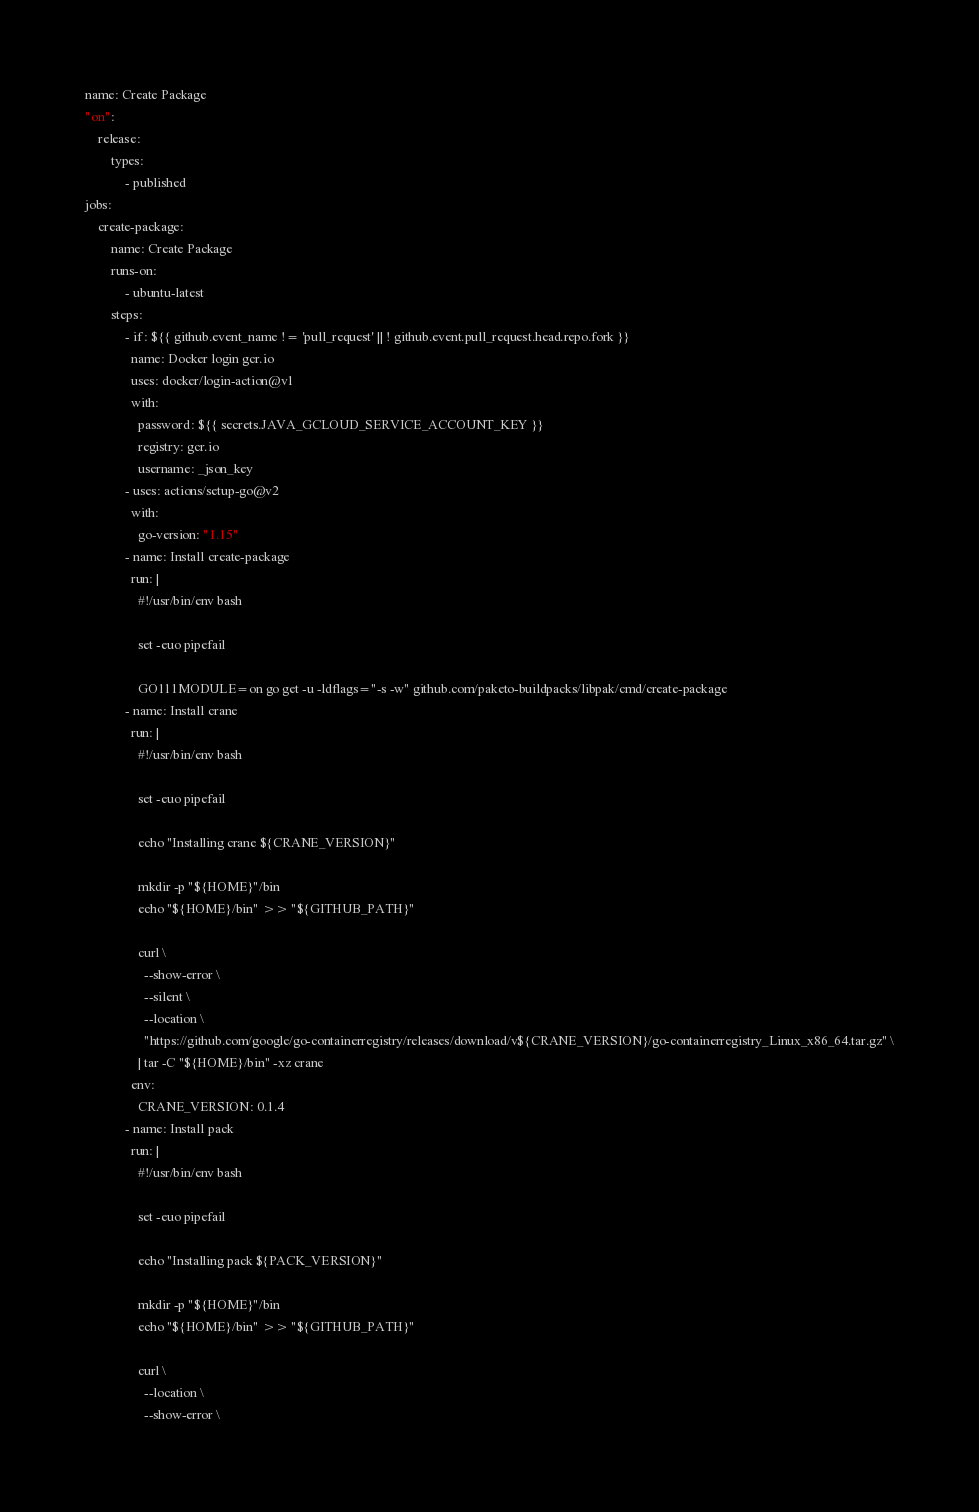<code> <loc_0><loc_0><loc_500><loc_500><_YAML_>name: Create Package
"on":
    release:
        types:
            - published
jobs:
    create-package:
        name: Create Package
        runs-on:
            - ubuntu-latest
        steps:
            - if: ${{ github.event_name != 'pull_request' || ! github.event.pull_request.head.repo.fork }}
              name: Docker login gcr.io
              uses: docker/login-action@v1
              with:
                password: ${{ secrets.JAVA_GCLOUD_SERVICE_ACCOUNT_KEY }}
                registry: gcr.io
                username: _json_key
            - uses: actions/setup-go@v2
              with:
                go-version: "1.15"
            - name: Install create-package
              run: |
                #!/usr/bin/env bash

                set -euo pipefail

                GO111MODULE=on go get -u -ldflags="-s -w" github.com/paketo-buildpacks/libpak/cmd/create-package
            - name: Install crane
              run: |
                #!/usr/bin/env bash

                set -euo pipefail

                echo "Installing crane ${CRANE_VERSION}"

                mkdir -p "${HOME}"/bin
                echo "${HOME}/bin" >> "${GITHUB_PATH}"

                curl \
                  --show-error \
                  --silent \
                  --location \
                  "https://github.com/google/go-containerregistry/releases/download/v${CRANE_VERSION}/go-containerregistry_Linux_x86_64.tar.gz" \
                | tar -C "${HOME}/bin" -xz crane
              env:
                CRANE_VERSION: 0.1.4
            - name: Install pack
              run: |
                #!/usr/bin/env bash

                set -euo pipefail

                echo "Installing pack ${PACK_VERSION}"

                mkdir -p "${HOME}"/bin
                echo "${HOME}/bin" >> "${GITHUB_PATH}"

                curl \
                  --location \
                  --show-error \</code> 